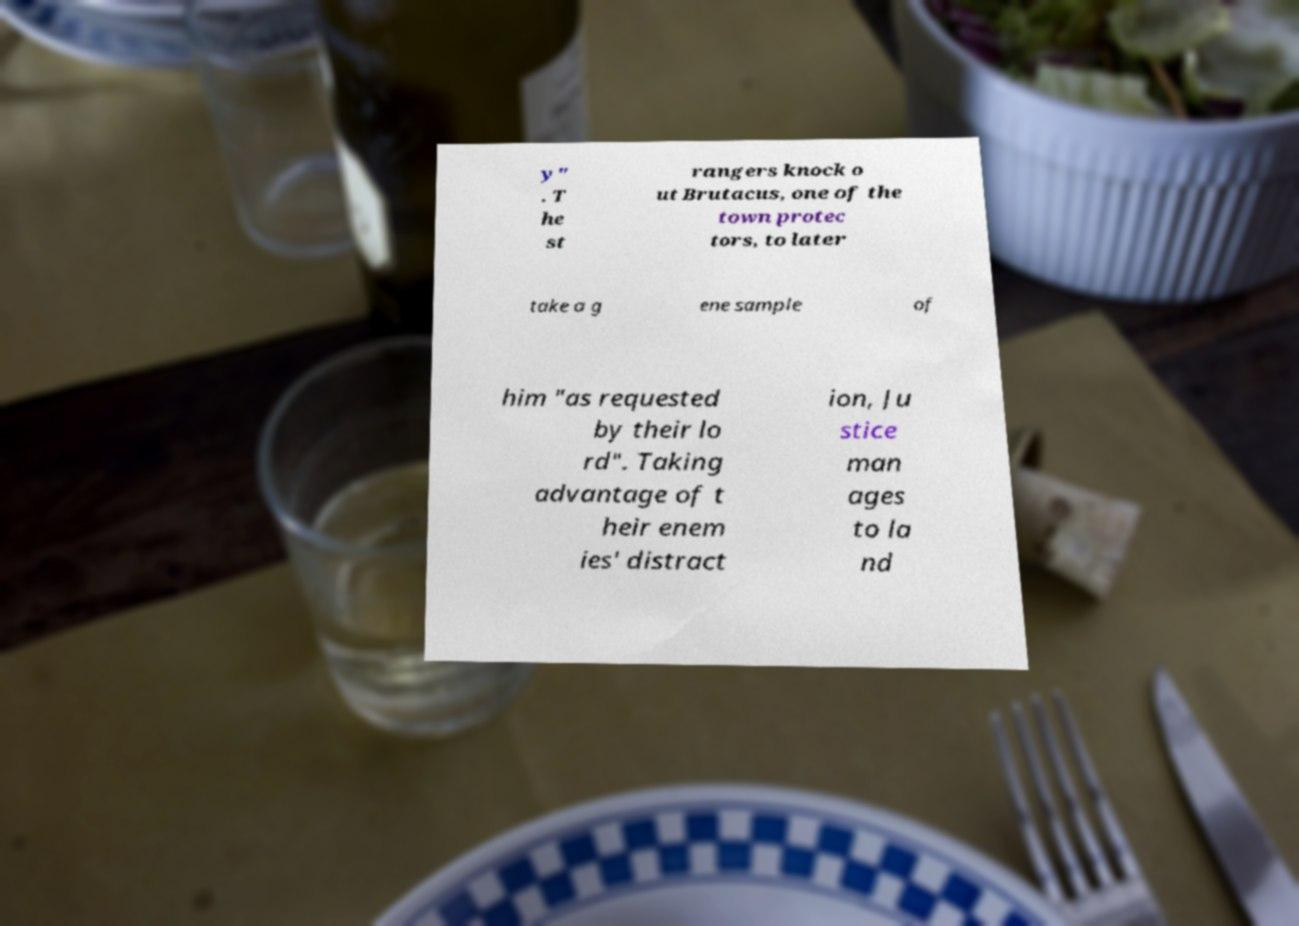Please read and relay the text visible in this image. What does it say? y" . T he st rangers knock o ut Brutacus, one of the town protec tors, to later take a g ene sample of him "as requested by their lo rd". Taking advantage of t heir enem ies' distract ion, Ju stice man ages to la nd 